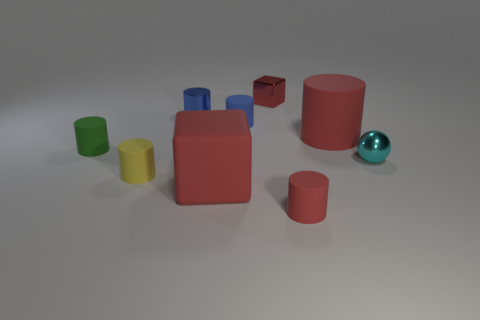Are there more red matte blocks on the left side of the blue metallic thing than big rubber cylinders?
Offer a terse response. No. How many cyan metal balls have the same size as the yellow rubber cylinder?
Offer a very short reply. 1. There is a red cube to the left of the small metallic block; is it the same size as the red matte cylinder that is in front of the big red cylinder?
Offer a terse response. No. Are there more small matte cylinders on the right side of the big matte block than small rubber objects that are to the right of the yellow cylinder?
Make the answer very short. No. What number of small green objects are the same shape as the small red rubber object?
Offer a very short reply. 1. What material is the cyan ball that is the same size as the red metallic block?
Your answer should be very brief. Metal. Are there any spheres that have the same material as the small red cube?
Your answer should be very brief. Yes. Is the number of small cyan objects that are left of the blue shiny object less than the number of large purple blocks?
Provide a short and direct response. No. The large red object that is behind the rubber object left of the tiny yellow rubber thing is made of what material?
Give a very brief answer. Rubber. There is a red thing that is both to the left of the big red cylinder and behind the tiny green matte cylinder; what shape is it?
Keep it short and to the point. Cube. 